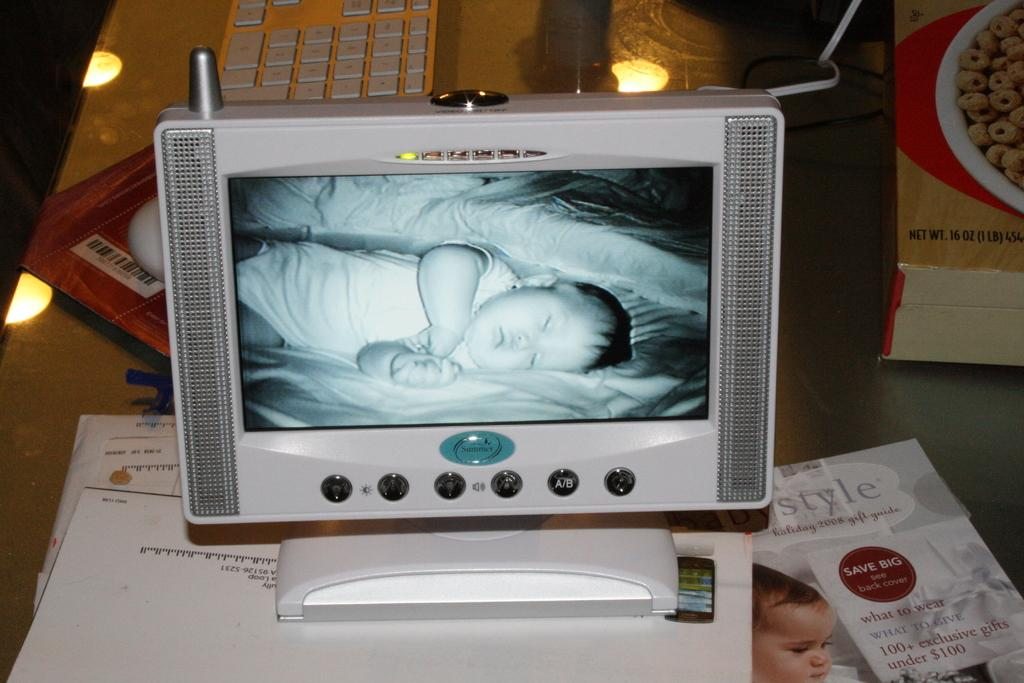Provide a one-sentence caption for the provided image. A holiday gift guide from 2008 advertises 100+ exclusive gifts under $100, and lies next to a monitor showing a sleeping baby. 